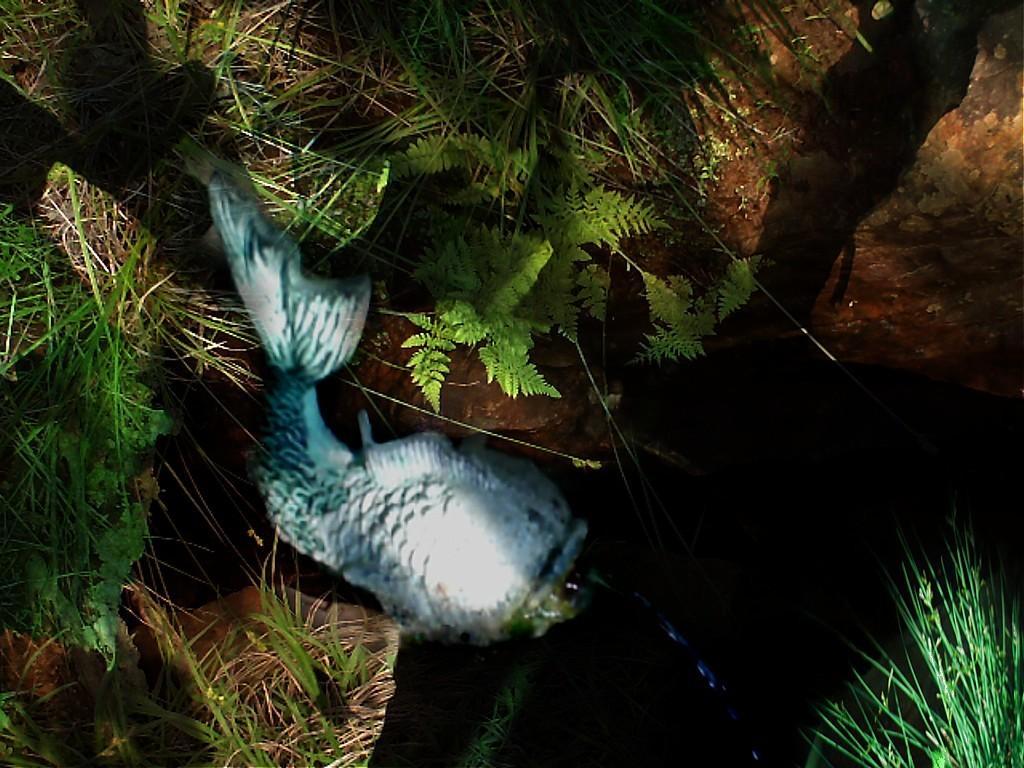In one or two sentences, can you explain what this image depicts? In this picture there is a statue of a fish and there are stones and there are plants. 